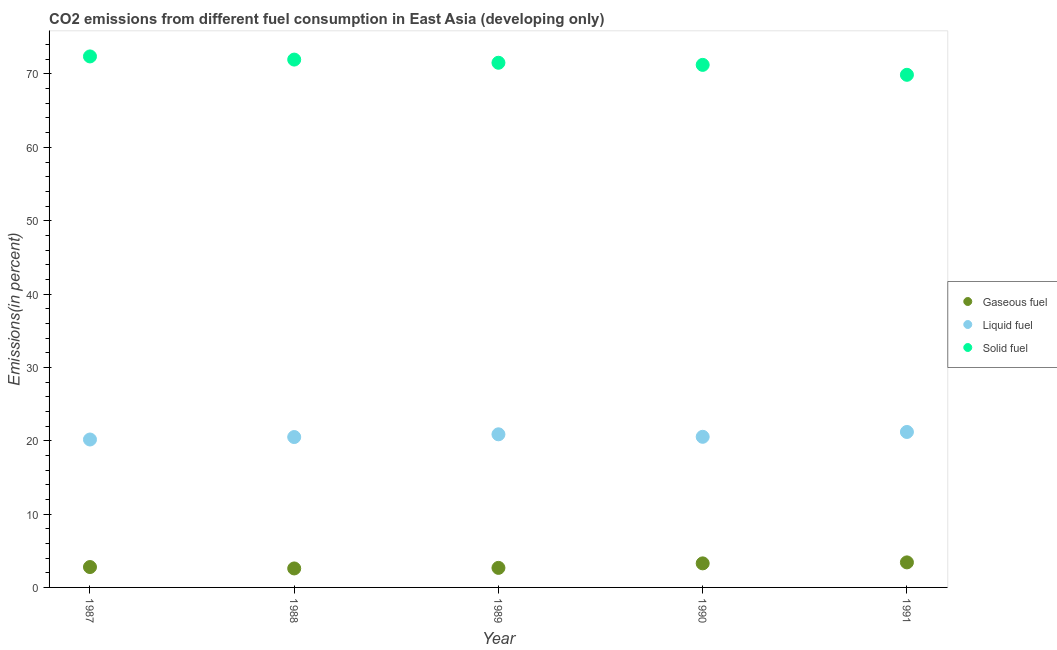How many different coloured dotlines are there?
Give a very brief answer. 3. Is the number of dotlines equal to the number of legend labels?
Your answer should be very brief. Yes. What is the percentage of solid fuel emission in 1987?
Offer a very short reply. 72.39. Across all years, what is the maximum percentage of liquid fuel emission?
Offer a very short reply. 21.19. Across all years, what is the minimum percentage of solid fuel emission?
Make the answer very short. 69.89. In which year was the percentage of liquid fuel emission minimum?
Give a very brief answer. 1987. What is the total percentage of liquid fuel emission in the graph?
Keep it short and to the point. 103.27. What is the difference between the percentage of solid fuel emission in 1988 and that in 1989?
Give a very brief answer. 0.43. What is the difference between the percentage of gaseous fuel emission in 1989 and the percentage of solid fuel emission in 1991?
Provide a succinct answer. -67.22. What is the average percentage of gaseous fuel emission per year?
Your response must be concise. 2.95. In the year 1988, what is the difference between the percentage of gaseous fuel emission and percentage of solid fuel emission?
Offer a very short reply. -69.38. In how many years, is the percentage of solid fuel emission greater than 12 %?
Make the answer very short. 5. What is the ratio of the percentage of liquid fuel emission in 1989 to that in 1991?
Offer a very short reply. 0.98. Is the percentage of solid fuel emission in 1990 less than that in 1991?
Your answer should be compact. No. Is the difference between the percentage of gaseous fuel emission in 1987 and 1989 greater than the difference between the percentage of liquid fuel emission in 1987 and 1989?
Keep it short and to the point. Yes. What is the difference between the highest and the second highest percentage of liquid fuel emission?
Give a very brief answer. 0.32. What is the difference between the highest and the lowest percentage of solid fuel emission?
Your answer should be compact. 2.51. Is it the case that in every year, the sum of the percentage of gaseous fuel emission and percentage of liquid fuel emission is greater than the percentage of solid fuel emission?
Keep it short and to the point. No. Is the percentage of solid fuel emission strictly greater than the percentage of liquid fuel emission over the years?
Your answer should be compact. Yes. Is the percentage of solid fuel emission strictly less than the percentage of gaseous fuel emission over the years?
Offer a terse response. No. How many years are there in the graph?
Offer a terse response. 5. Are the values on the major ticks of Y-axis written in scientific E-notation?
Your response must be concise. No. Does the graph contain any zero values?
Make the answer very short. No. How many legend labels are there?
Make the answer very short. 3. What is the title of the graph?
Your answer should be compact. CO2 emissions from different fuel consumption in East Asia (developing only). Does "Grants" appear as one of the legend labels in the graph?
Provide a succinct answer. No. What is the label or title of the Y-axis?
Offer a terse response. Emissions(in percent). What is the Emissions(in percent) in Gaseous fuel in 1987?
Provide a short and direct response. 2.78. What is the Emissions(in percent) in Liquid fuel in 1987?
Keep it short and to the point. 20.17. What is the Emissions(in percent) in Solid fuel in 1987?
Your answer should be compact. 72.39. What is the Emissions(in percent) of Gaseous fuel in 1988?
Provide a succinct answer. 2.59. What is the Emissions(in percent) in Liquid fuel in 1988?
Your answer should be very brief. 20.5. What is the Emissions(in percent) of Solid fuel in 1988?
Give a very brief answer. 71.96. What is the Emissions(in percent) of Gaseous fuel in 1989?
Your answer should be compact. 2.67. What is the Emissions(in percent) in Liquid fuel in 1989?
Offer a very short reply. 20.88. What is the Emissions(in percent) in Solid fuel in 1989?
Provide a short and direct response. 71.53. What is the Emissions(in percent) of Gaseous fuel in 1990?
Offer a very short reply. 3.28. What is the Emissions(in percent) of Liquid fuel in 1990?
Provide a succinct answer. 20.53. What is the Emissions(in percent) in Solid fuel in 1990?
Keep it short and to the point. 71.24. What is the Emissions(in percent) in Gaseous fuel in 1991?
Your answer should be compact. 3.41. What is the Emissions(in percent) in Liquid fuel in 1991?
Offer a very short reply. 21.19. What is the Emissions(in percent) of Solid fuel in 1991?
Ensure brevity in your answer.  69.89. Across all years, what is the maximum Emissions(in percent) in Gaseous fuel?
Offer a terse response. 3.41. Across all years, what is the maximum Emissions(in percent) of Liquid fuel?
Keep it short and to the point. 21.19. Across all years, what is the maximum Emissions(in percent) in Solid fuel?
Keep it short and to the point. 72.39. Across all years, what is the minimum Emissions(in percent) in Gaseous fuel?
Ensure brevity in your answer.  2.59. Across all years, what is the minimum Emissions(in percent) of Liquid fuel?
Give a very brief answer. 20.17. Across all years, what is the minimum Emissions(in percent) of Solid fuel?
Your answer should be compact. 69.89. What is the total Emissions(in percent) in Gaseous fuel in the graph?
Keep it short and to the point. 14.73. What is the total Emissions(in percent) of Liquid fuel in the graph?
Your answer should be compact. 103.27. What is the total Emissions(in percent) in Solid fuel in the graph?
Offer a very short reply. 357.02. What is the difference between the Emissions(in percent) in Gaseous fuel in 1987 and that in 1988?
Make the answer very short. 0.19. What is the difference between the Emissions(in percent) of Liquid fuel in 1987 and that in 1988?
Keep it short and to the point. -0.34. What is the difference between the Emissions(in percent) of Solid fuel in 1987 and that in 1988?
Offer a terse response. 0.43. What is the difference between the Emissions(in percent) in Gaseous fuel in 1987 and that in 1989?
Keep it short and to the point. 0.11. What is the difference between the Emissions(in percent) of Liquid fuel in 1987 and that in 1989?
Your response must be concise. -0.71. What is the difference between the Emissions(in percent) of Solid fuel in 1987 and that in 1989?
Keep it short and to the point. 0.86. What is the difference between the Emissions(in percent) in Gaseous fuel in 1987 and that in 1990?
Ensure brevity in your answer.  -0.5. What is the difference between the Emissions(in percent) in Liquid fuel in 1987 and that in 1990?
Keep it short and to the point. -0.37. What is the difference between the Emissions(in percent) in Solid fuel in 1987 and that in 1990?
Make the answer very short. 1.15. What is the difference between the Emissions(in percent) of Gaseous fuel in 1987 and that in 1991?
Make the answer very short. -0.63. What is the difference between the Emissions(in percent) of Liquid fuel in 1987 and that in 1991?
Provide a short and direct response. -1.03. What is the difference between the Emissions(in percent) of Solid fuel in 1987 and that in 1991?
Your answer should be very brief. 2.51. What is the difference between the Emissions(in percent) in Gaseous fuel in 1988 and that in 1989?
Your answer should be very brief. -0.08. What is the difference between the Emissions(in percent) of Liquid fuel in 1988 and that in 1989?
Your answer should be very brief. -0.37. What is the difference between the Emissions(in percent) in Solid fuel in 1988 and that in 1989?
Ensure brevity in your answer.  0.43. What is the difference between the Emissions(in percent) of Gaseous fuel in 1988 and that in 1990?
Your answer should be very brief. -0.69. What is the difference between the Emissions(in percent) of Liquid fuel in 1988 and that in 1990?
Your answer should be very brief. -0.03. What is the difference between the Emissions(in percent) of Solid fuel in 1988 and that in 1990?
Give a very brief answer. 0.72. What is the difference between the Emissions(in percent) of Gaseous fuel in 1988 and that in 1991?
Your answer should be very brief. -0.83. What is the difference between the Emissions(in percent) in Liquid fuel in 1988 and that in 1991?
Provide a short and direct response. -0.69. What is the difference between the Emissions(in percent) in Solid fuel in 1988 and that in 1991?
Your answer should be very brief. 2.08. What is the difference between the Emissions(in percent) of Gaseous fuel in 1989 and that in 1990?
Keep it short and to the point. -0.61. What is the difference between the Emissions(in percent) in Liquid fuel in 1989 and that in 1990?
Give a very brief answer. 0.34. What is the difference between the Emissions(in percent) in Solid fuel in 1989 and that in 1990?
Your answer should be compact. 0.29. What is the difference between the Emissions(in percent) in Gaseous fuel in 1989 and that in 1991?
Provide a short and direct response. -0.75. What is the difference between the Emissions(in percent) of Liquid fuel in 1989 and that in 1991?
Give a very brief answer. -0.32. What is the difference between the Emissions(in percent) of Solid fuel in 1989 and that in 1991?
Offer a very short reply. 1.64. What is the difference between the Emissions(in percent) in Gaseous fuel in 1990 and that in 1991?
Your answer should be compact. -0.13. What is the difference between the Emissions(in percent) in Liquid fuel in 1990 and that in 1991?
Make the answer very short. -0.66. What is the difference between the Emissions(in percent) of Solid fuel in 1990 and that in 1991?
Offer a very short reply. 1.35. What is the difference between the Emissions(in percent) of Gaseous fuel in 1987 and the Emissions(in percent) of Liquid fuel in 1988?
Your response must be concise. -17.72. What is the difference between the Emissions(in percent) in Gaseous fuel in 1987 and the Emissions(in percent) in Solid fuel in 1988?
Your response must be concise. -69.18. What is the difference between the Emissions(in percent) in Liquid fuel in 1987 and the Emissions(in percent) in Solid fuel in 1988?
Make the answer very short. -51.8. What is the difference between the Emissions(in percent) in Gaseous fuel in 1987 and the Emissions(in percent) in Liquid fuel in 1989?
Make the answer very short. -18.1. What is the difference between the Emissions(in percent) in Gaseous fuel in 1987 and the Emissions(in percent) in Solid fuel in 1989?
Your response must be concise. -68.75. What is the difference between the Emissions(in percent) of Liquid fuel in 1987 and the Emissions(in percent) of Solid fuel in 1989?
Provide a short and direct response. -51.36. What is the difference between the Emissions(in percent) in Gaseous fuel in 1987 and the Emissions(in percent) in Liquid fuel in 1990?
Give a very brief answer. -17.75. What is the difference between the Emissions(in percent) in Gaseous fuel in 1987 and the Emissions(in percent) in Solid fuel in 1990?
Provide a succinct answer. -68.46. What is the difference between the Emissions(in percent) of Liquid fuel in 1987 and the Emissions(in percent) of Solid fuel in 1990?
Offer a terse response. -51.08. What is the difference between the Emissions(in percent) in Gaseous fuel in 1987 and the Emissions(in percent) in Liquid fuel in 1991?
Ensure brevity in your answer.  -18.41. What is the difference between the Emissions(in percent) of Gaseous fuel in 1987 and the Emissions(in percent) of Solid fuel in 1991?
Your response must be concise. -67.11. What is the difference between the Emissions(in percent) in Liquid fuel in 1987 and the Emissions(in percent) in Solid fuel in 1991?
Your answer should be compact. -49.72. What is the difference between the Emissions(in percent) of Gaseous fuel in 1988 and the Emissions(in percent) of Liquid fuel in 1989?
Your answer should be very brief. -18.29. What is the difference between the Emissions(in percent) in Gaseous fuel in 1988 and the Emissions(in percent) in Solid fuel in 1989?
Ensure brevity in your answer.  -68.94. What is the difference between the Emissions(in percent) in Liquid fuel in 1988 and the Emissions(in percent) in Solid fuel in 1989?
Your answer should be compact. -51.03. What is the difference between the Emissions(in percent) of Gaseous fuel in 1988 and the Emissions(in percent) of Liquid fuel in 1990?
Ensure brevity in your answer.  -17.95. What is the difference between the Emissions(in percent) of Gaseous fuel in 1988 and the Emissions(in percent) of Solid fuel in 1990?
Your response must be concise. -68.66. What is the difference between the Emissions(in percent) in Liquid fuel in 1988 and the Emissions(in percent) in Solid fuel in 1990?
Your answer should be very brief. -50.74. What is the difference between the Emissions(in percent) in Gaseous fuel in 1988 and the Emissions(in percent) in Liquid fuel in 1991?
Your response must be concise. -18.61. What is the difference between the Emissions(in percent) of Gaseous fuel in 1988 and the Emissions(in percent) of Solid fuel in 1991?
Offer a terse response. -67.3. What is the difference between the Emissions(in percent) in Liquid fuel in 1988 and the Emissions(in percent) in Solid fuel in 1991?
Your answer should be compact. -49.39. What is the difference between the Emissions(in percent) in Gaseous fuel in 1989 and the Emissions(in percent) in Liquid fuel in 1990?
Provide a short and direct response. -17.87. What is the difference between the Emissions(in percent) in Gaseous fuel in 1989 and the Emissions(in percent) in Solid fuel in 1990?
Ensure brevity in your answer.  -68.58. What is the difference between the Emissions(in percent) of Liquid fuel in 1989 and the Emissions(in percent) of Solid fuel in 1990?
Ensure brevity in your answer.  -50.37. What is the difference between the Emissions(in percent) in Gaseous fuel in 1989 and the Emissions(in percent) in Liquid fuel in 1991?
Offer a very short reply. -18.53. What is the difference between the Emissions(in percent) in Gaseous fuel in 1989 and the Emissions(in percent) in Solid fuel in 1991?
Your response must be concise. -67.22. What is the difference between the Emissions(in percent) in Liquid fuel in 1989 and the Emissions(in percent) in Solid fuel in 1991?
Make the answer very short. -49.01. What is the difference between the Emissions(in percent) in Gaseous fuel in 1990 and the Emissions(in percent) in Liquid fuel in 1991?
Your answer should be compact. -17.92. What is the difference between the Emissions(in percent) in Gaseous fuel in 1990 and the Emissions(in percent) in Solid fuel in 1991?
Provide a short and direct response. -66.61. What is the difference between the Emissions(in percent) of Liquid fuel in 1990 and the Emissions(in percent) of Solid fuel in 1991?
Keep it short and to the point. -49.35. What is the average Emissions(in percent) in Gaseous fuel per year?
Offer a very short reply. 2.95. What is the average Emissions(in percent) of Liquid fuel per year?
Provide a short and direct response. 20.65. What is the average Emissions(in percent) in Solid fuel per year?
Give a very brief answer. 71.4. In the year 1987, what is the difference between the Emissions(in percent) of Gaseous fuel and Emissions(in percent) of Liquid fuel?
Offer a terse response. -17.39. In the year 1987, what is the difference between the Emissions(in percent) in Gaseous fuel and Emissions(in percent) in Solid fuel?
Your answer should be very brief. -69.61. In the year 1987, what is the difference between the Emissions(in percent) in Liquid fuel and Emissions(in percent) in Solid fuel?
Give a very brief answer. -52.23. In the year 1988, what is the difference between the Emissions(in percent) in Gaseous fuel and Emissions(in percent) in Liquid fuel?
Make the answer very short. -17.91. In the year 1988, what is the difference between the Emissions(in percent) in Gaseous fuel and Emissions(in percent) in Solid fuel?
Offer a terse response. -69.38. In the year 1988, what is the difference between the Emissions(in percent) in Liquid fuel and Emissions(in percent) in Solid fuel?
Give a very brief answer. -51.46. In the year 1989, what is the difference between the Emissions(in percent) of Gaseous fuel and Emissions(in percent) of Liquid fuel?
Keep it short and to the point. -18.21. In the year 1989, what is the difference between the Emissions(in percent) of Gaseous fuel and Emissions(in percent) of Solid fuel?
Provide a succinct answer. -68.87. In the year 1989, what is the difference between the Emissions(in percent) of Liquid fuel and Emissions(in percent) of Solid fuel?
Provide a short and direct response. -50.66. In the year 1990, what is the difference between the Emissions(in percent) in Gaseous fuel and Emissions(in percent) in Liquid fuel?
Keep it short and to the point. -17.25. In the year 1990, what is the difference between the Emissions(in percent) of Gaseous fuel and Emissions(in percent) of Solid fuel?
Provide a short and direct response. -67.96. In the year 1990, what is the difference between the Emissions(in percent) in Liquid fuel and Emissions(in percent) in Solid fuel?
Keep it short and to the point. -50.71. In the year 1991, what is the difference between the Emissions(in percent) in Gaseous fuel and Emissions(in percent) in Liquid fuel?
Your response must be concise. -17.78. In the year 1991, what is the difference between the Emissions(in percent) in Gaseous fuel and Emissions(in percent) in Solid fuel?
Keep it short and to the point. -66.47. In the year 1991, what is the difference between the Emissions(in percent) of Liquid fuel and Emissions(in percent) of Solid fuel?
Give a very brief answer. -48.69. What is the ratio of the Emissions(in percent) of Gaseous fuel in 1987 to that in 1988?
Ensure brevity in your answer.  1.07. What is the ratio of the Emissions(in percent) in Liquid fuel in 1987 to that in 1988?
Provide a short and direct response. 0.98. What is the ratio of the Emissions(in percent) in Gaseous fuel in 1987 to that in 1989?
Provide a succinct answer. 1.04. What is the ratio of the Emissions(in percent) in Liquid fuel in 1987 to that in 1989?
Provide a succinct answer. 0.97. What is the ratio of the Emissions(in percent) of Solid fuel in 1987 to that in 1989?
Provide a short and direct response. 1.01. What is the ratio of the Emissions(in percent) of Gaseous fuel in 1987 to that in 1990?
Give a very brief answer. 0.85. What is the ratio of the Emissions(in percent) in Liquid fuel in 1987 to that in 1990?
Your response must be concise. 0.98. What is the ratio of the Emissions(in percent) of Solid fuel in 1987 to that in 1990?
Give a very brief answer. 1.02. What is the ratio of the Emissions(in percent) of Gaseous fuel in 1987 to that in 1991?
Offer a very short reply. 0.81. What is the ratio of the Emissions(in percent) of Liquid fuel in 1987 to that in 1991?
Your answer should be compact. 0.95. What is the ratio of the Emissions(in percent) of Solid fuel in 1987 to that in 1991?
Provide a succinct answer. 1.04. What is the ratio of the Emissions(in percent) in Gaseous fuel in 1988 to that in 1989?
Ensure brevity in your answer.  0.97. What is the ratio of the Emissions(in percent) in Liquid fuel in 1988 to that in 1989?
Ensure brevity in your answer.  0.98. What is the ratio of the Emissions(in percent) in Solid fuel in 1988 to that in 1989?
Keep it short and to the point. 1.01. What is the ratio of the Emissions(in percent) of Gaseous fuel in 1988 to that in 1990?
Provide a succinct answer. 0.79. What is the ratio of the Emissions(in percent) of Liquid fuel in 1988 to that in 1990?
Your answer should be compact. 1. What is the ratio of the Emissions(in percent) of Gaseous fuel in 1988 to that in 1991?
Offer a terse response. 0.76. What is the ratio of the Emissions(in percent) in Liquid fuel in 1988 to that in 1991?
Ensure brevity in your answer.  0.97. What is the ratio of the Emissions(in percent) of Solid fuel in 1988 to that in 1991?
Provide a succinct answer. 1.03. What is the ratio of the Emissions(in percent) in Gaseous fuel in 1989 to that in 1990?
Offer a very short reply. 0.81. What is the ratio of the Emissions(in percent) in Liquid fuel in 1989 to that in 1990?
Give a very brief answer. 1.02. What is the ratio of the Emissions(in percent) of Solid fuel in 1989 to that in 1990?
Your response must be concise. 1. What is the ratio of the Emissions(in percent) in Gaseous fuel in 1989 to that in 1991?
Offer a very short reply. 0.78. What is the ratio of the Emissions(in percent) in Liquid fuel in 1989 to that in 1991?
Your answer should be compact. 0.98. What is the ratio of the Emissions(in percent) of Solid fuel in 1989 to that in 1991?
Offer a very short reply. 1.02. What is the ratio of the Emissions(in percent) of Gaseous fuel in 1990 to that in 1991?
Give a very brief answer. 0.96. What is the ratio of the Emissions(in percent) in Liquid fuel in 1990 to that in 1991?
Give a very brief answer. 0.97. What is the ratio of the Emissions(in percent) of Solid fuel in 1990 to that in 1991?
Provide a short and direct response. 1.02. What is the difference between the highest and the second highest Emissions(in percent) of Gaseous fuel?
Ensure brevity in your answer.  0.13. What is the difference between the highest and the second highest Emissions(in percent) in Liquid fuel?
Offer a very short reply. 0.32. What is the difference between the highest and the second highest Emissions(in percent) in Solid fuel?
Make the answer very short. 0.43. What is the difference between the highest and the lowest Emissions(in percent) of Gaseous fuel?
Provide a short and direct response. 0.83. What is the difference between the highest and the lowest Emissions(in percent) in Liquid fuel?
Your answer should be very brief. 1.03. What is the difference between the highest and the lowest Emissions(in percent) of Solid fuel?
Your answer should be compact. 2.51. 